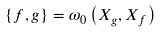Convert formula to latex. <formula><loc_0><loc_0><loc_500><loc_500>\left \{ f , g \right \} = \omega _ { 0 } \left ( X _ { g } , X _ { f } \right )</formula> 